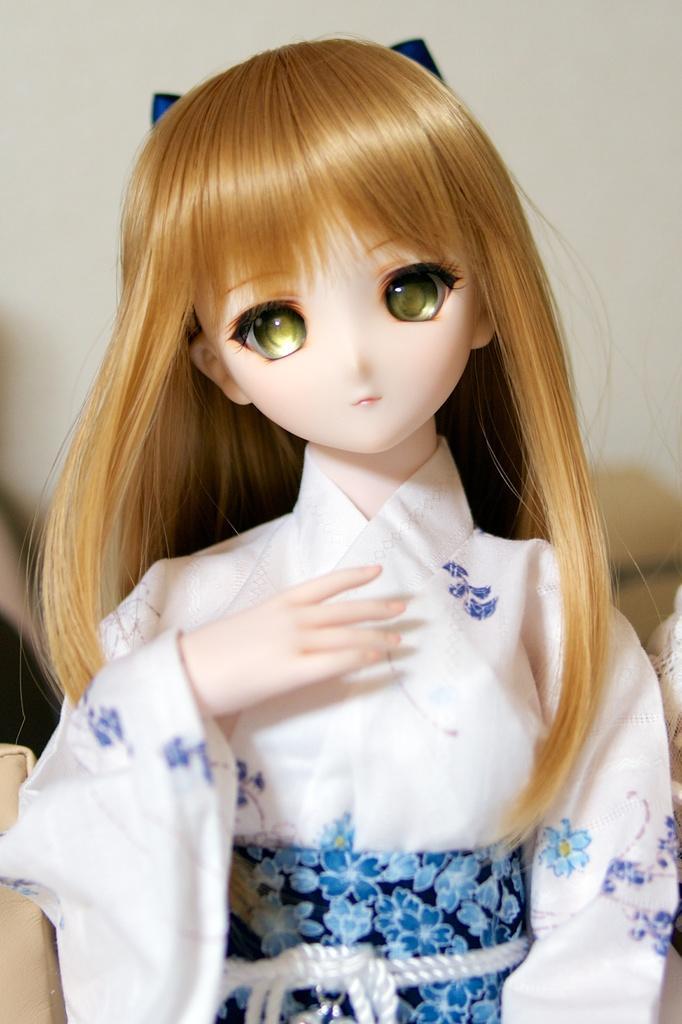How would you summarize this image in a sentence or two? In this image there is a doll and there are some objects. And at the background it looks like blur. 